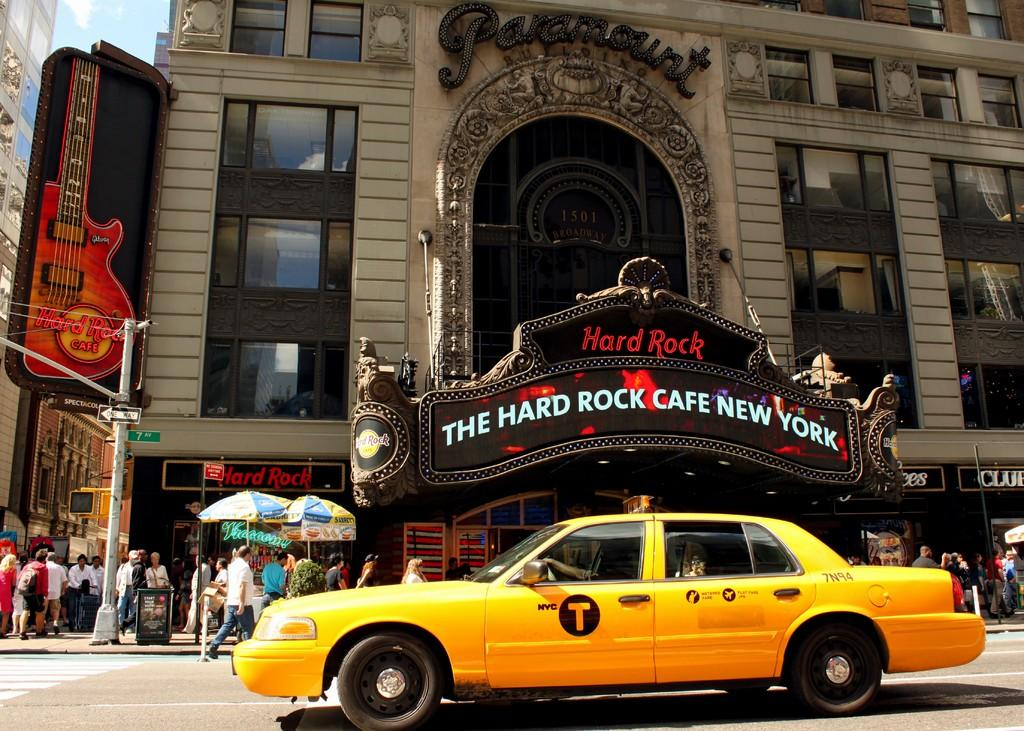<image>
Describe the image concisely. a taxi next to a hard rock building on its right 